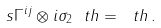Convert formula to latex. <formula><loc_0><loc_0><loc_500><loc_500>s \Gamma ^ { i j } \otimes i \sigma _ { 2 } \ t h = \ t h \, .</formula> 